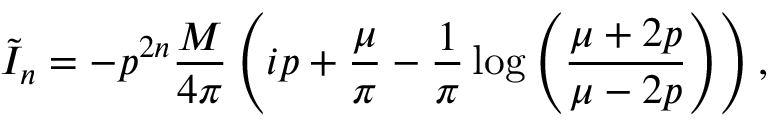<formula> <loc_0><loc_0><loc_500><loc_500>\tilde { I } _ { n } = - p ^ { 2 n } \frac { M } { 4 \pi } \left ( i p + \frac { \mu } { \pi } - \frac { 1 } { \pi } \log \left ( \frac { \mu + 2 p } { \mu - 2 p } \right ) \right ) ,</formula> 